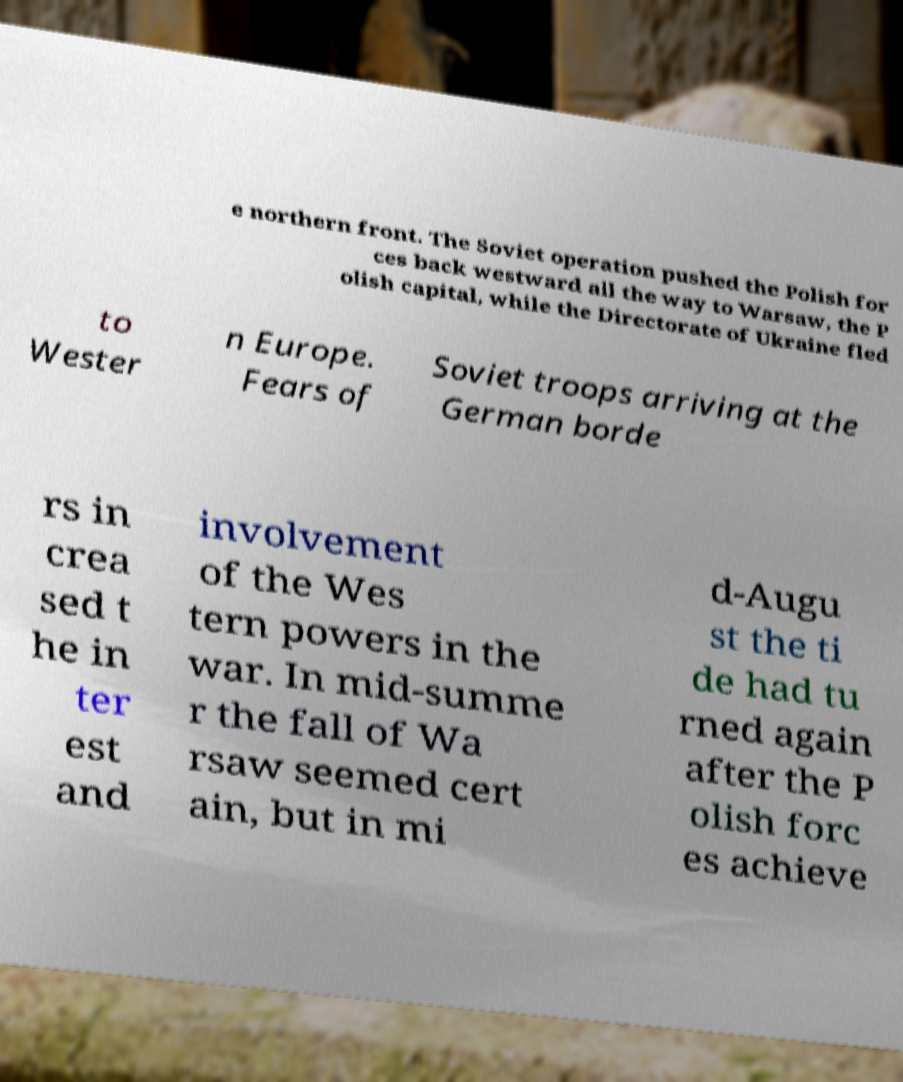Could you extract and type out the text from this image? e northern front. The Soviet operation pushed the Polish for ces back westward all the way to Warsaw, the P olish capital, while the Directorate of Ukraine fled to Wester n Europe. Fears of Soviet troops arriving at the German borde rs in crea sed t he in ter est and involvement of the Wes tern powers in the war. In mid-summe r the fall of Wa rsaw seemed cert ain, but in mi d-Augu st the ti de had tu rned again after the P olish forc es achieve 